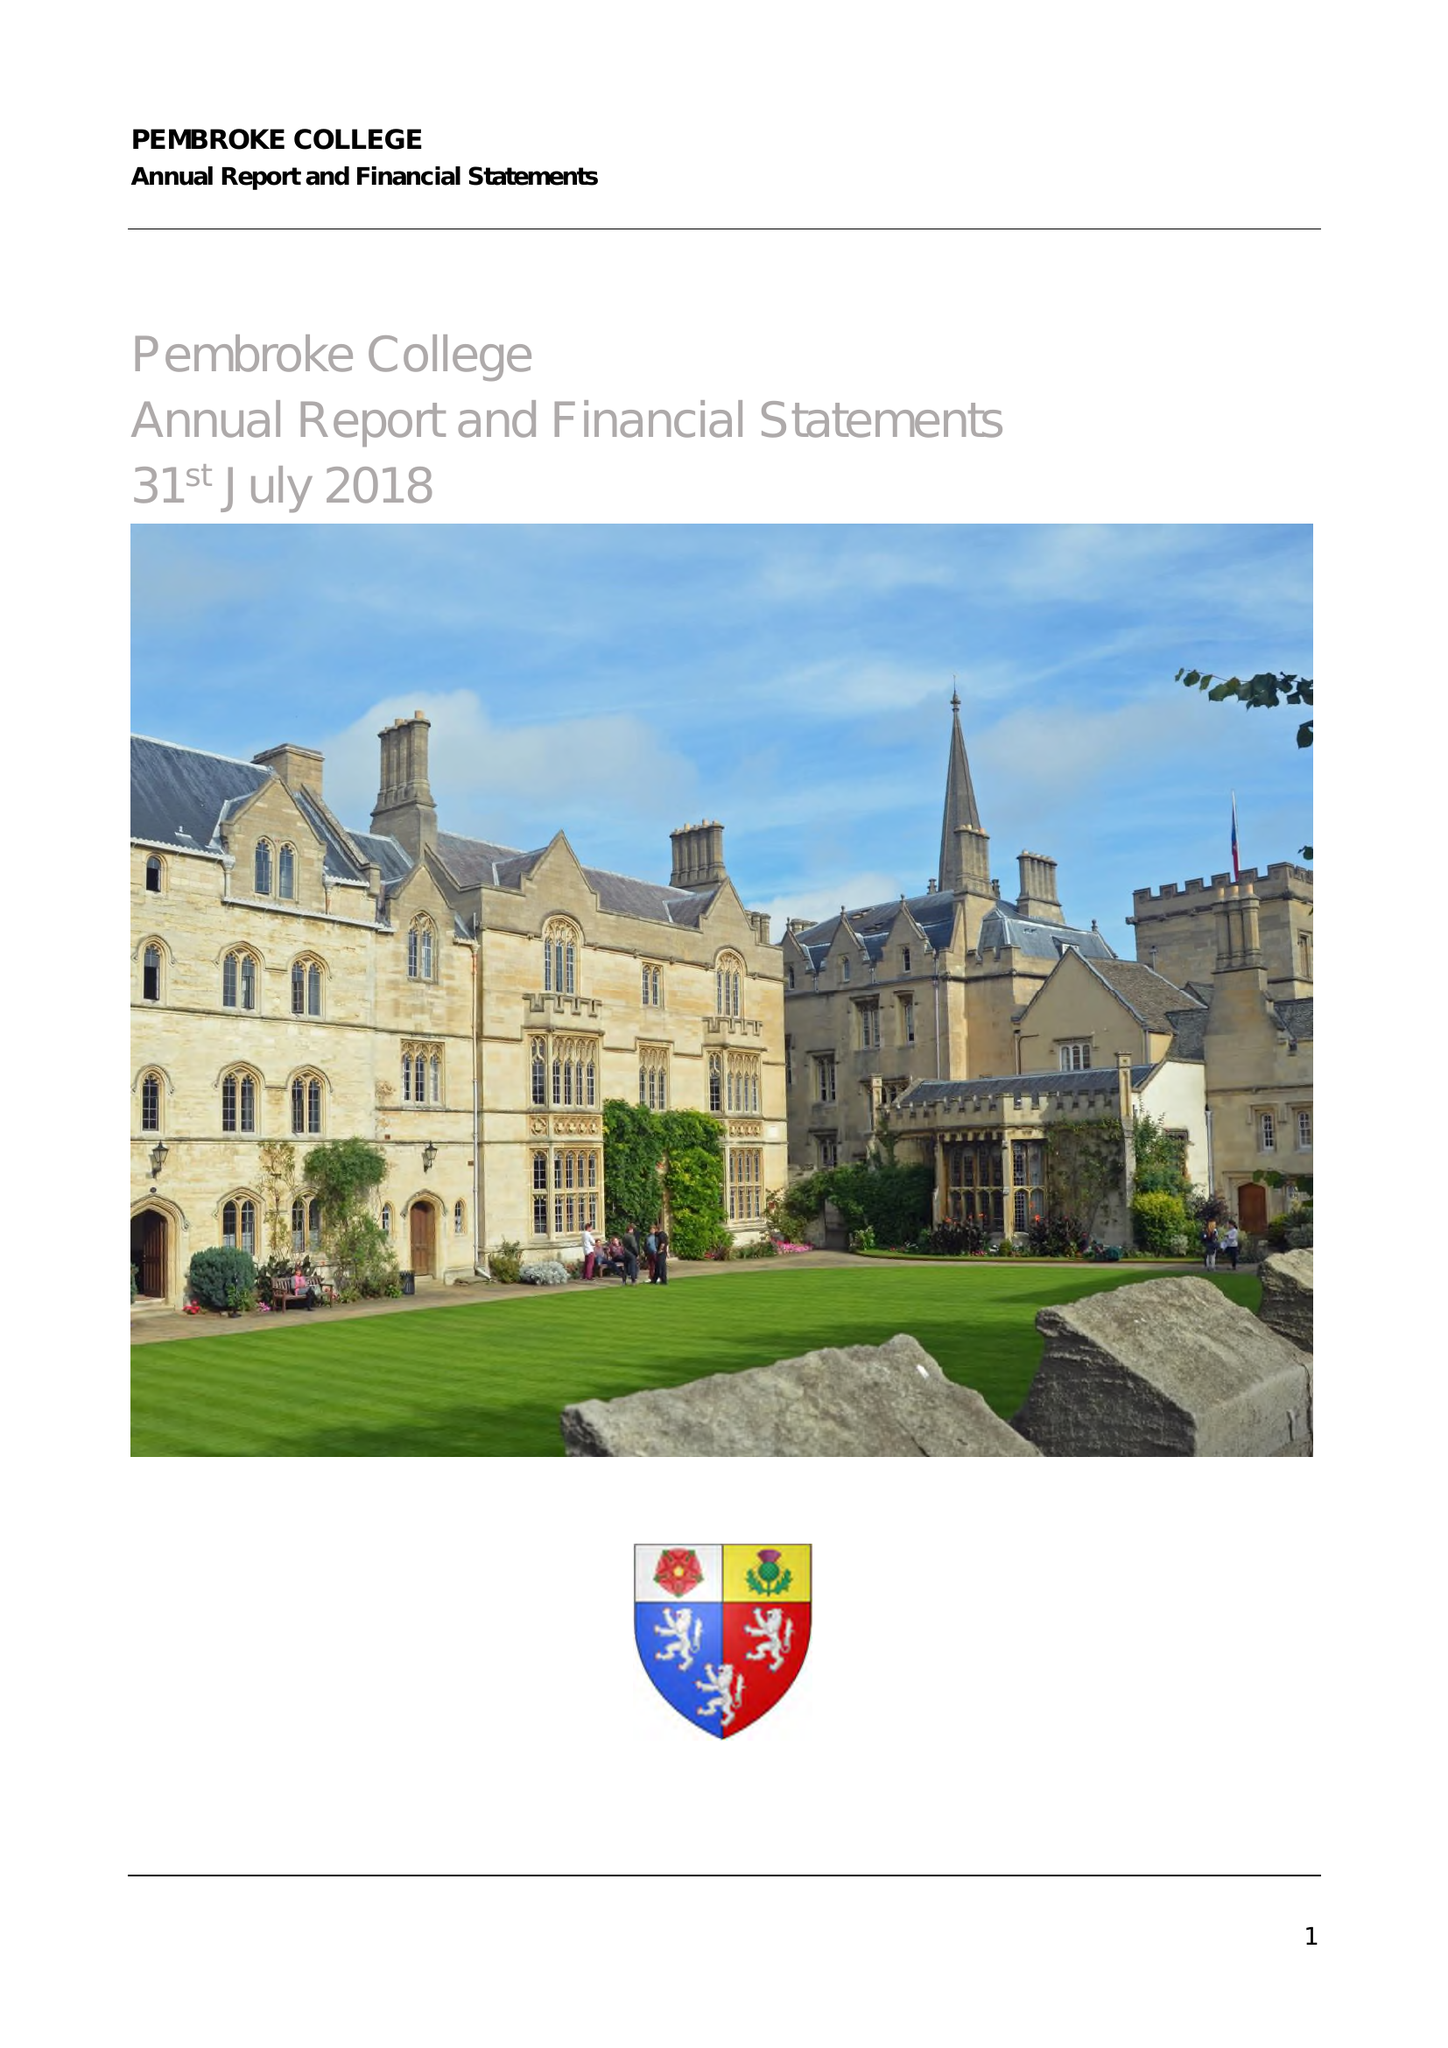What is the value for the spending_annually_in_british_pounds?
Answer the question using a single word or phrase. 11671300.00 